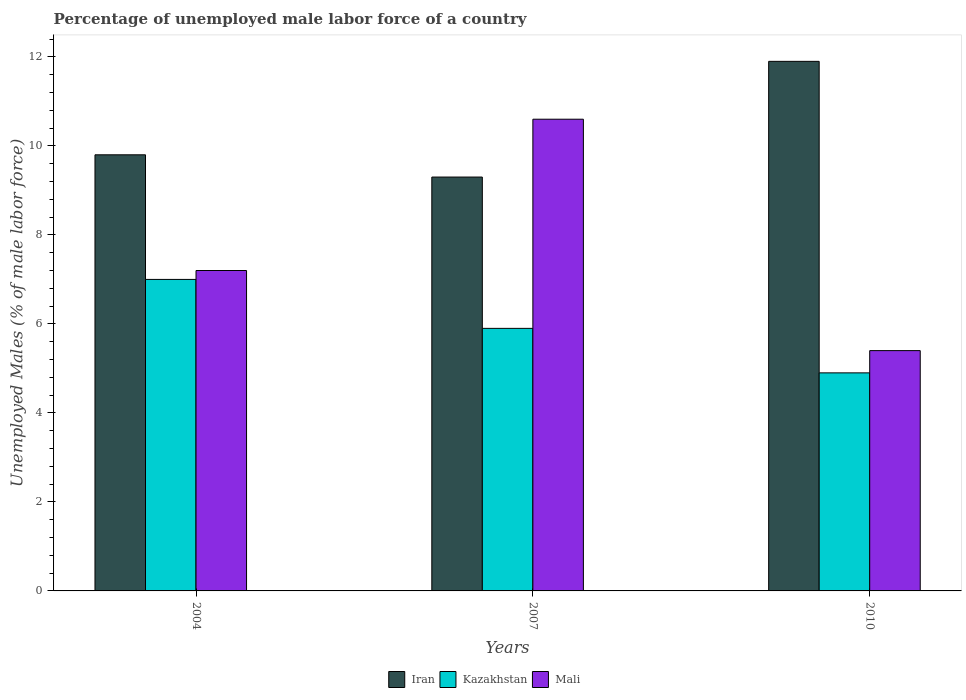How many different coloured bars are there?
Provide a short and direct response. 3. How many groups of bars are there?
Keep it short and to the point. 3. Are the number of bars per tick equal to the number of legend labels?
Make the answer very short. Yes. How many bars are there on the 3rd tick from the right?
Provide a short and direct response. 3. What is the label of the 3rd group of bars from the left?
Offer a very short reply. 2010. What is the percentage of unemployed male labor force in Mali in 2010?
Provide a short and direct response. 5.4. Across all years, what is the maximum percentage of unemployed male labor force in Iran?
Provide a succinct answer. 11.9. Across all years, what is the minimum percentage of unemployed male labor force in Mali?
Provide a succinct answer. 5.4. In which year was the percentage of unemployed male labor force in Iran maximum?
Make the answer very short. 2010. In which year was the percentage of unemployed male labor force in Kazakhstan minimum?
Offer a terse response. 2010. What is the total percentage of unemployed male labor force in Kazakhstan in the graph?
Your answer should be compact. 17.8. What is the difference between the percentage of unemployed male labor force in Kazakhstan in 2007 and that in 2010?
Offer a very short reply. 1. What is the difference between the percentage of unemployed male labor force in Kazakhstan in 2007 and the percentage of unemployed male labor force in Mali in 2004?
Provide a succinct answer. -1.3. What is the average percentage of unemployed male labor force in Kazakhstan per year?
Offer a very short reply. 5.93. In the year 2007, what is the difference between the percentage of unemployed male labor force in Iran and percentage of unemployed male labor force in Kazakhstan?
Ensure brevity in your answer.  3.4. In how many years, is the percentage of unemployed male labor force in Mali greater than 9.6 %?
Make the answer very short. 1. What is the ratio of the percentage of unemployed male labor force in Iran in 2004 to that in 2007?
Your response must be concise. 1.05. Is the difference between the percentage of unemployed male labor force in Iran in 2004 and 2007 greater than the difference between the percentage of unemployed male labor force in Kazakhstan in 2004 and 2007?
Your response must be concise. No. What is the difference between the highest and the second highest percentage of unemployed male labor force in Iran?
Offer a very short reply. 2.1. What is the difference between the highest and the lowest percentage of unemployed male labor force in Mali?
Your answer should be very brief. 5.2. In how many years, is the percentage of unemployed male labor force in Kazakhstan greater than the average percentage of unemployed male labor force in Kazakhstan taken over all years?
Make the answer very short. 1. What does the 2nd bar from the left in 2007 represents?
Provide a short and direct response. Kazakhstan. What does the 1st bar from the right in 2007 represents?
Ensure brevity in your answer.  Mali. Is it the case that in every year, the sum of the percentage of unemployed male labor force in Iran and percentage of unemployed male labor force in Mali is greater than the percentage of unemployed male labor force in Kazakhstan?
Offer a very short reply. Yes. Are all the bars in the graph horizontal?
Make the answer very short. No. How many years are there in the graph?
Your response must be concise. 3. Where does the legend appear in the graph?
Make the answer very short. Bottom center. What is the title of the graph?
Your answer should be very brief. Percentage of unemployed male labor force of a country. What is the label or title of the Y-axis?
Keep it short and to the point. Unemployed Males (% of male labor force). What is the Unemployed Males (% of male labor force) of Iran in 2004?
Provide a succinct answer. 9.8. What is the Unemployed Males (% of male labor force) of Mali in 2004?
Your response must be concise. 7.2. What is the Unemployed Males (% of male labor force) of Iran in 2007?
Your answer should be very brief. 9.3. What is the Unemployed Males (% of male labor force) of Kazakhstan in 2007?
Offer a very short reply. 5.9. What is the Unemployed Males (% of male labor force) of Mali in 2007?
Offer a terse response. 10.6. What is the Unemployed Males (% of male labor force) in Iran in 2010?
Your answer should be compact. 11.9. What is the Unemployed Males (% of male labor force) in Kazakhstan in 2010?
Make the answer very short. 4.9. What is the Unemployed Males (% of male labor force) in Mali in 2010?
Your answer should be very brief. 5.4. Across all years, what is the maximum Unemployed Males (% of male labor force) in Iran?
Your response must be concise. 11.9. Across all years, what is the maximum Unemployed Males (% of male labor force) in Mali?
Keep it short and to the point. 10.6. Across all years, what is the minimum Unemployed Males (% of male labor force) of Iran?
Provide a short and direct response. 9.3. Across all years, what is the minimum Unemployed Males (% of male labor force) in Kazakhstan?
Your response must be concise. 4.9. Across all years, what is the minimum Unemployed Males (% of male labor force) in Mali?
Your answer should be compact. 5.4. What is the total Unemployed Males (% of male labor force) of Kazakhstan in the graph?
Your response must be concise. 17.8. What is the total Unemployed Males (% of male labor force) of Mali in the graph?
Offer a very short reply. 23.2. What is the difference between the Unemployed Males (% of male labor force) in Iran in 2004 and that in 2007?
Make the answer very short. 0.5. What is the difference between the Unemployed Males (% of male labor force) in Mali in 2004 and that in 2007?
Your response must be concise. -3.4. What is the difference between the Unemployed Males (% of male labor force) of Iran in 2004 and the Unemployed Males (% of male labor force) of Kazakhstan in 2007?
Offer a terse response. 3.9. What is the difference between the Unemployed Males (% of male labor force) in Kazakhstan in 2004 and the Unemployed Males (% of male labor force) in Mali in 2007?
Make the answer very short. -3.6. What is the difference between the Unemployed Males (% of male labor force) of Iran in 2004 and the Unemployed Males (% of male labor force) of Kazakhstan in 2010?
Provide a succinct answer. 4.9. What is the difference between the Unemployed Males (% of male labor force) of Iran in 2004 and the Unemployed Males (% of male labor force) of Mali in 2010?
Make the answer very short. 4.4. What is the difference between the Unemployed Males (% of male labor force) in Kazakhstan in 2007 and the Unemployed Males (% of male labor force) in Mali in 2010?
Offer a terse response. 0.5. What is the average Unemployed Males (% of male labor force) in Iran per year?
Provide a short and direct response. 10.33. What is the average Unemployed Males (% of male labor force) of Kazakhstan per year?
Your response must be concise. 5.93. What is the average Unemployed Males (% of male labor force) of Mali per year?
Make the answer very short. 7.73. In the year 2004, what is the difference between the Unemployed Males (% of male labor force) of Iran and Unemployed Males (% of male labor force) of Kazakhstan?
Provide a succinct answer. 2.8. In the year 2004, what is the difference between the Unemployed Males (% of male labor force) of Iran and Unemployed Males (% of male labor force) of Mali?
Provide a short and direct response. 2.6. In the year 2007, what is the difference between the Unemployed Males (% of male labor force) of Iran and Unemployed Males (% of male labor force) of Mali?
Offer a very short reply. -1.3. In the year 2010, what is the difference between the Unemployed Males (% of male labor force) in Iran and Unemployed Males (% of male labor force) in Kazakhstan?
Offer a terse response. 7. In the year 2010, what is the difference between the Unemployed Males (% of male labor force) of Iran and Unemployed Males (% of male labor force) of Mali?
Offer a terse response. 6.5. What is the ratio of the Unemployed Males (% of male labor force) of Iran in 2004 to that in 2007?
Offer a terse response. 1.05. What is the ratio of the Unemployed Males (% of male labor force) of Kazakhstan in 2004 to that in 2007?
Provide a succinct answer. 1.19. What is the ratio of the Unemployed Males (% of male labor force) in Mali in 2004 to that in 2007?
Your response must be concise. 0.68. What is the ratio of the Unemployed Males (% of male labor force) in Iran in 2004 to that in 2010?
Provide a short and direct response. 0.82. What is the ratio of the Unemployed Males (% of male labor force) of Kazakhstan in 2004 to that in 2010?
Ensure brevity in your answer.  1.43. What is the ratio of the Unemployed Males (% of male labor force) of Mali in 2004 to that in 2010?
Provide a short and direct response. 1.33. What is the ratio of the Unemployed Males (% of male labor force) of Iran in 2007 to that in 2010?
Your response must be concise. 0.78. What is the ratio of the Unemployed Males (% of male labor force) of Kazakhstan in 2007 to that in 2010?
Give a very brief answer. 1.2. What is the ratio of the Unemployed Males (% of male labor force) of Mali in 2007 to that in 2010?
Provide a succinct answer. 1.96. What is the difference between the highest and the lowest Unemployed Males (% of male labor force) in Iran?
Provide a short and direct response. 2.6. What is the difference between the highest and the lowest Unemployed Males (% of male labor force) in Kazakhstan?
Your answer should be very brief. 2.1. What is the difference between the highest and the lowest Unemployed Males (% of male labor force) in Mali?
Your response must be concise. 5.2. 